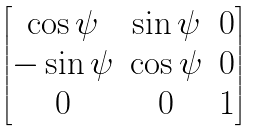<formula> <loc_0><loc_0><loc_500><loc_500>\begin{bmatrix} \cos \psi & \sin \psi & 0 \\ - \sin \psi & \cos \psi & 0 \\ 0 & 0 & 1 \end{bmatrix}</formula> 